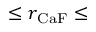<formula> <loc_0><loc_0><loc_500><loc_500>\leq r _ { C a F } \leq</formula> 